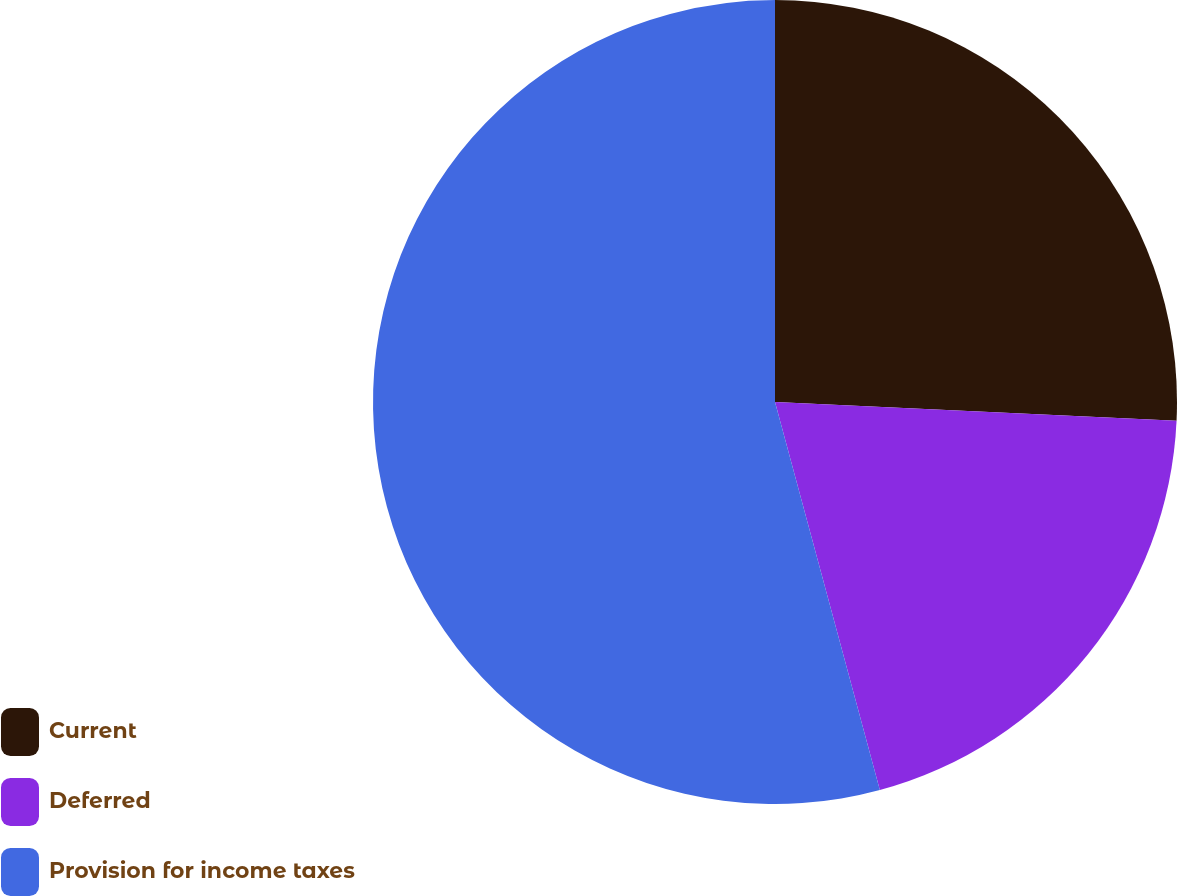Convert chart. <chart><loc_0><loc_0><loc_500><loc_500><pie_chart><fcel>Current<fcel>Deferred<fcel>Provision for income taxes<nl><fcel>25.74%<fcel>20.06%<fcel>54.2%<nl></chart> 